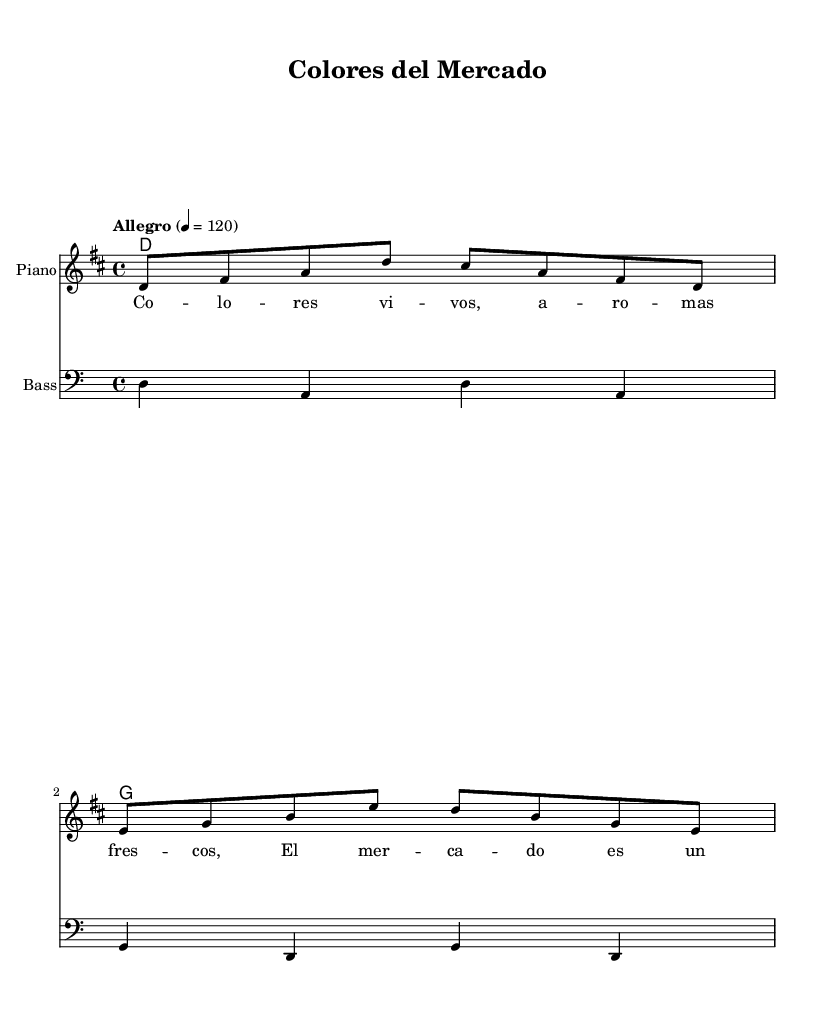What is the key signature of this music? The key signature is D major, which is indicated by two sharps (F# and C#).
Answer: D major What is the time signature? The time signature is 4/4, which is shown at the beginning of the piece.
Answer: 4/4 What is the tempo marking? The tempo marking is "Allegro" with a specific BPM of 120, indicating a fast-paced performance.
Answer: Allegro, 120 How many measures are in the melody? The melody consists of two measures as indicated by the grouping of eight notes in the given section.
Answer: 2 What is the instrumentation used in this piece? The instrumentation includes piano and bass, as specified in the staff descriptions.
Answer: Piano, Bass What is the title of the piece? The title is "Colores del Mercado," which is indicated at the top of the sheet music.
Answer: Colores del Mercado What lyrical theme is present in the lyrics? The lyrics describe colorful aspects of a marketplace, as expressed in the first line.
Answer: Colorful marketplaces 